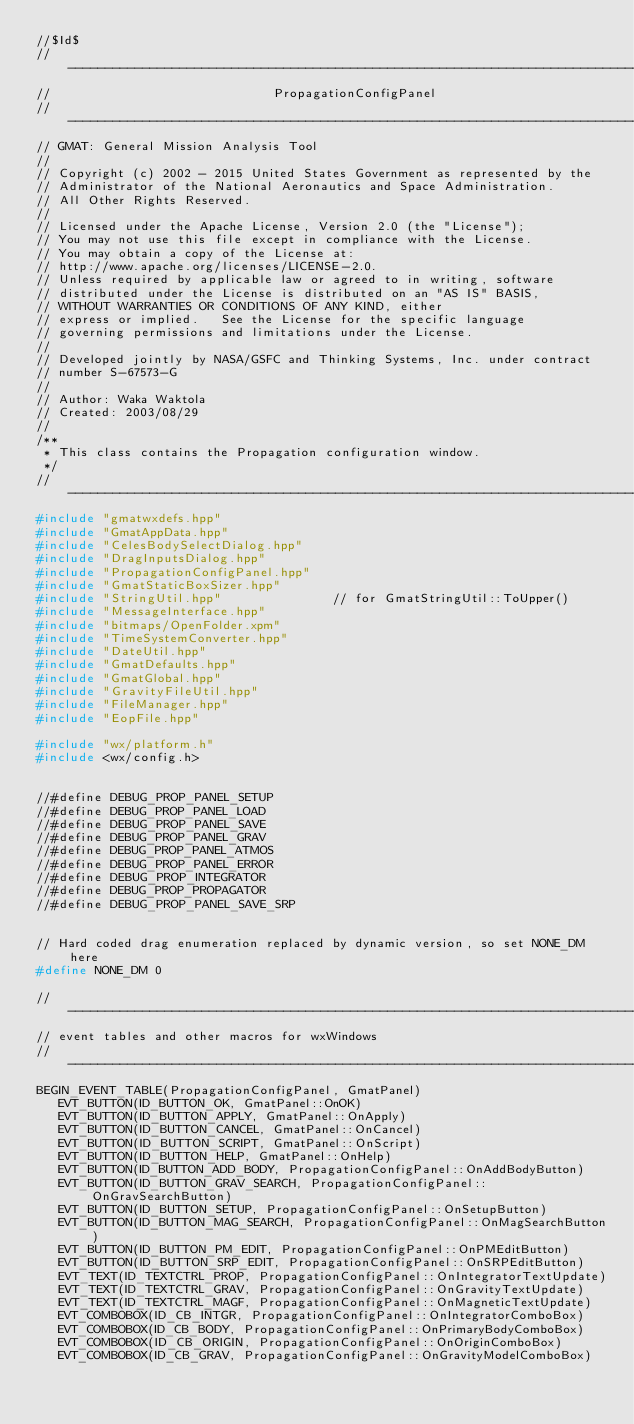Convert code to text. <code><loc_0><loc_0><loc_500><loc_500><_C++_>//$Id$
//------------------------------------------------------------------------------
//                              PropagationConfigPanel
//------------------------------------------------------------------------------
// GMAT: General Mission Analysis Tool
//
// Copyright (c) 2002 - 2015 United States Government as represented by the
// Administrator of the National Aeronautics and Space Administration.
// All Other Rights Reserved.
//
// Licensed under the Apache License, Version 2.0 (the "License"); 
// You may not use this file except in compliance with the License. 
// You may obtain a copy of the License at:
// http://www.apache.org/licenses/LICENSE-2.0. 
// Unless required by applicable law or agreed to in writing, software
// distributed under the License is distributed on an "AS IS" BASIS,
// WITHOUT WARRANTIES OR CONDITIONS OF ANY KIND, either 
// express or implied.   See the License for the specific language
// governing permissions and limitations under the License.
//
// Developed jointly by NASA/GSFC and Thinking Systems, Inc. under contract
// number S-67573-G
//
// Author: Waka Waktola
// Created: 2003/08/29
//
/**
 * This class contains the Propagation configuration window.
 */
//------------------------------------------------------------------------------
#include "gmatwxdefs.hpp"
#include "GmatAppData.hpp"
#include "CelesBodySelectDialog.hpp"
#include "DragInputsDialog.hpp"
#include "PropagationConfigPanel.hpp"
#include "GmatStaticBoxSizer.hpp"
#include "StringUtil.hpp"               // for GmatStringUtil::ToUpper()
#include "MessageInterface.hpp"
#include "bitmaps/OpenFolder.xpm"
#include "TimeSystemConverter.hpp"
#include "DateUtil.hpp"
#include "GmatDefaults.hpp"
#include "GmatGlobal.hpp"
#include "GravityFileUtil.hpp"
#include "FileManager.hpp"
#include "EopFile.hpp"

#include "wx/platform.h"
#include <wx/config.h>


//#define DEBUG_PROP_PANEL_SETUP
//#define DEBUG_PROP_PANEL_LOAD
//#define DEBUG_PROP_PANEL_SAVE
//#define DEBUG_PROP_PANEL_GRAV
//#define DEBUG_PROP_PANEL_ATMOS
//#define DEBUG_PROP_PANEL_ERROR
//#define DEBUG_PROP_INTEGRATOR
//#define DEBUG_PROP_PROPAGATOR
//#define DEBUG_PROP_PANEL_SAVE_SRP


// Hard coded drag enumeration replaced by dynamic version, so set NONE_DM here
#define NONE_DM 0

//------------------------------------------------------------------------------
// event tables and other macros for wxWindows
//------------------------------------------------------------------------------
BEGIN_EVENT_TABLE(PropagationConfigPanel, GmatPanel)
   EVT_BUTTON(ID_BUTTON_OK, GmatPanel::OnOK)
   EVT_BUTTON(ID_BUTTON_APPLY, GmatPanel::OnApply)
   EVT_BUTTON(ID_BUTTON_CANCEL, GmatPanel::OnCancel)
   EVT_BUTTON(ID_BUTTON_SCRIPT, GmatPanel::OnScript)
   EVT_BUTTON(ID_BUTTON_HELP, GmatPanel::OnHelp)
   EVT_BUTTON(ID_BUTTON_ADD_BODY, PropagationConfigPanel::OnAddBodyButton)
   EVT_BUTTON(ID_BUTTON_GRAV_SEARCH, PropagationConfigPanel::OnGravSearchButton)
   EVT_BUTTON(ID_BUTTON_SETUP, PropagationConfigPanel::OnSetupButton)
   EVT_BUTTON(ID_BUTTON_MAG_SEARCH, PropagationConfigPanel::OnMagSearchButton)
   EVT_BUTTON(ID_BUTTON_PM_EDIT, PropagationConfigPanel::OnPMEditButton)
   EVT_BUTTON(ID_BUTTON_SRP_EDIT, PropagationConfigPanel::OnSRPEditButton)
   EVT_TEXT(ID_TEXTCTRL_PROP, PropagationConfigPanel::OnIntegratorTextUpdate)
   EVT_TEXT(ID_TEXTCTRL_GRAV, PropagationConfigPanel::OnGravityTextUpdate)
   EVT_TEXT(ID_TEXTCTRL_MAGF, PropagationConfigPanel::OnMagneticTextUpdate)
   EVT_COMBOBOX(ID_CB_INTGR, PropagationConfigPanel::OnIntegratorComboBox)
   EVT_COMBOBOX(ID_CB_BODY, PropagationConfigPanel::OnPrimaryBodyComboBox)
   EVT_COMBOBOX(ID_CB_ORIGIN, PropagationConfigPanel::OnOriginComboBox)
   EVT_COMBOBOX(ID_CB_GRAV, PropagationConfigPanel::OnGravityModelComboBox)</code> 